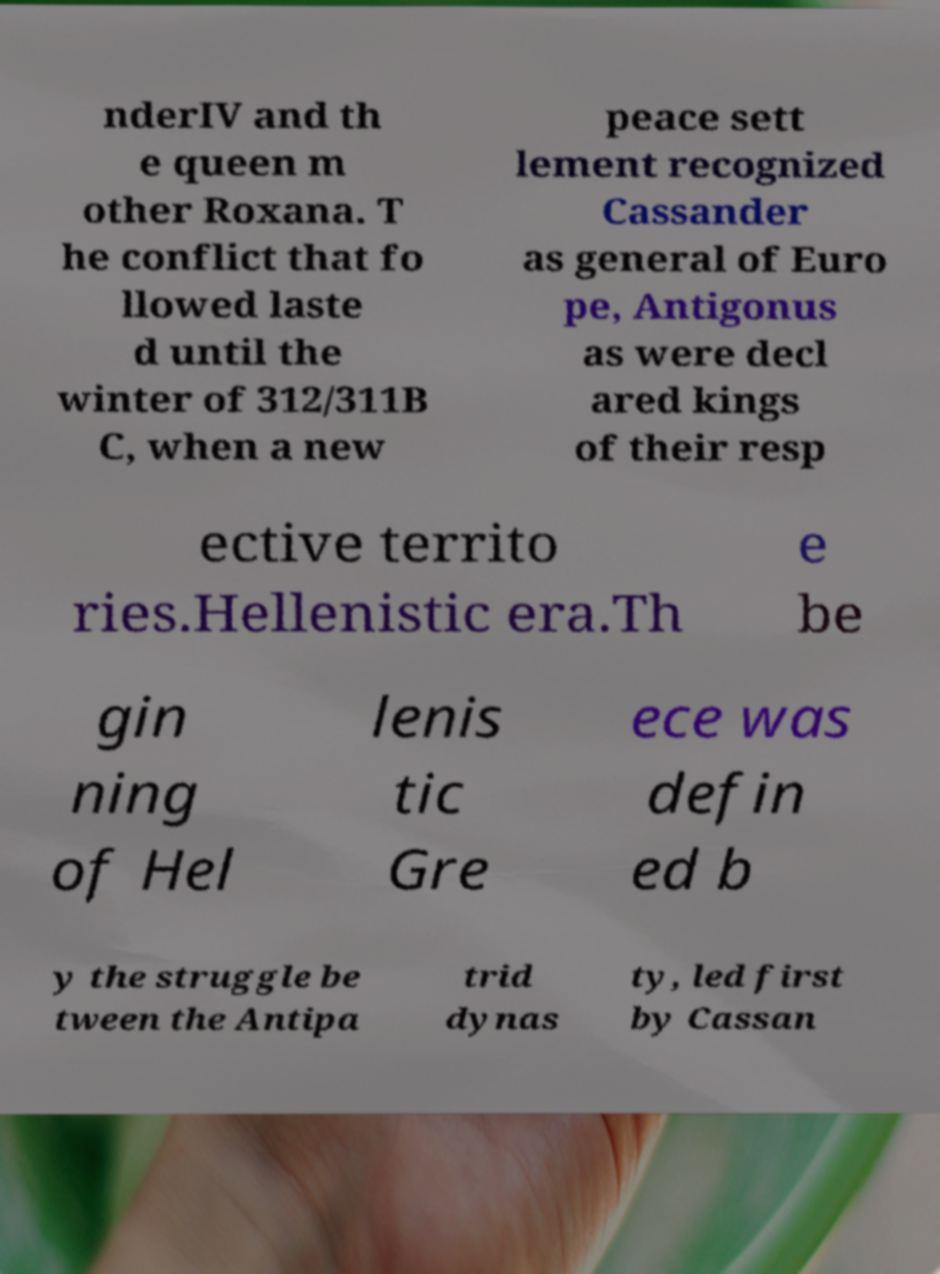What messages or text are displayed in this image? I need them in a readable, typed format. nderIV and th e queen m other Roxana. T he conflict that fo llowed laste d until the winter of 312/311B C, when a new peace sett lement recognized Cassander as general of Euro pe, Antigonus as were decl ared kings of their resp ective territo ries.Hellenistic era.Th e be gin ning of Hel lenis tic Gre ece was defin ed b y the struggle be tween the Antipa trid dynas ty, led first by Cassan 